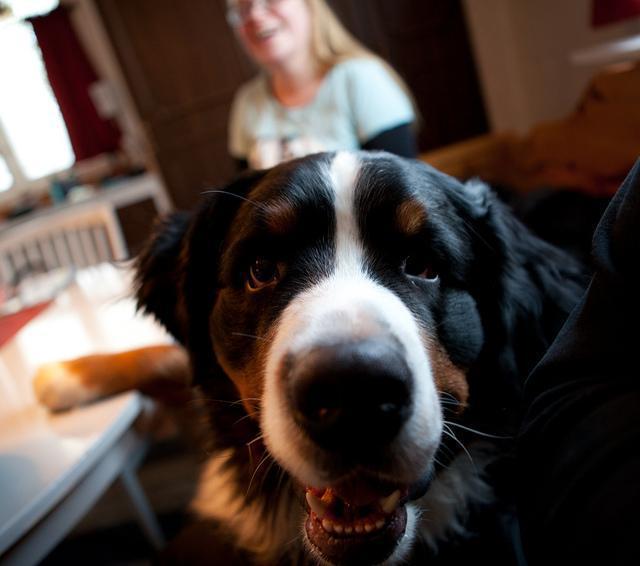What are they looking at?
Indicate the correct response by choosing from the four available options to answer the question.
Options: Photographer, dog, walls, table. Photographer. 